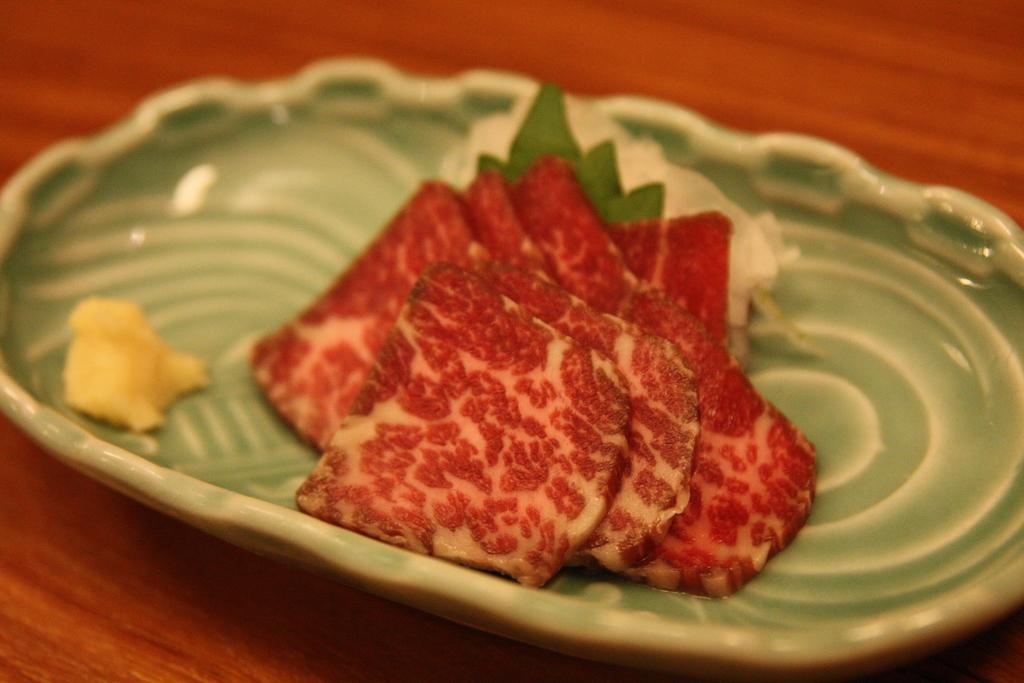Could you give a brief overview of what you see in this image? These are the food items in a plate. 